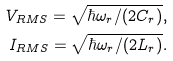<formula> <loc_0><loc_0><loc_500><loc_500>V _ { R M S } = \sqrt { \hbar { \omega } _ { r } / ( 2 C _ { r } ) } , \\ I _ { R M S } = \sqrt { \hbar { \omega } _ { r } / ( 2 L _ { r } ) } .</formula> 